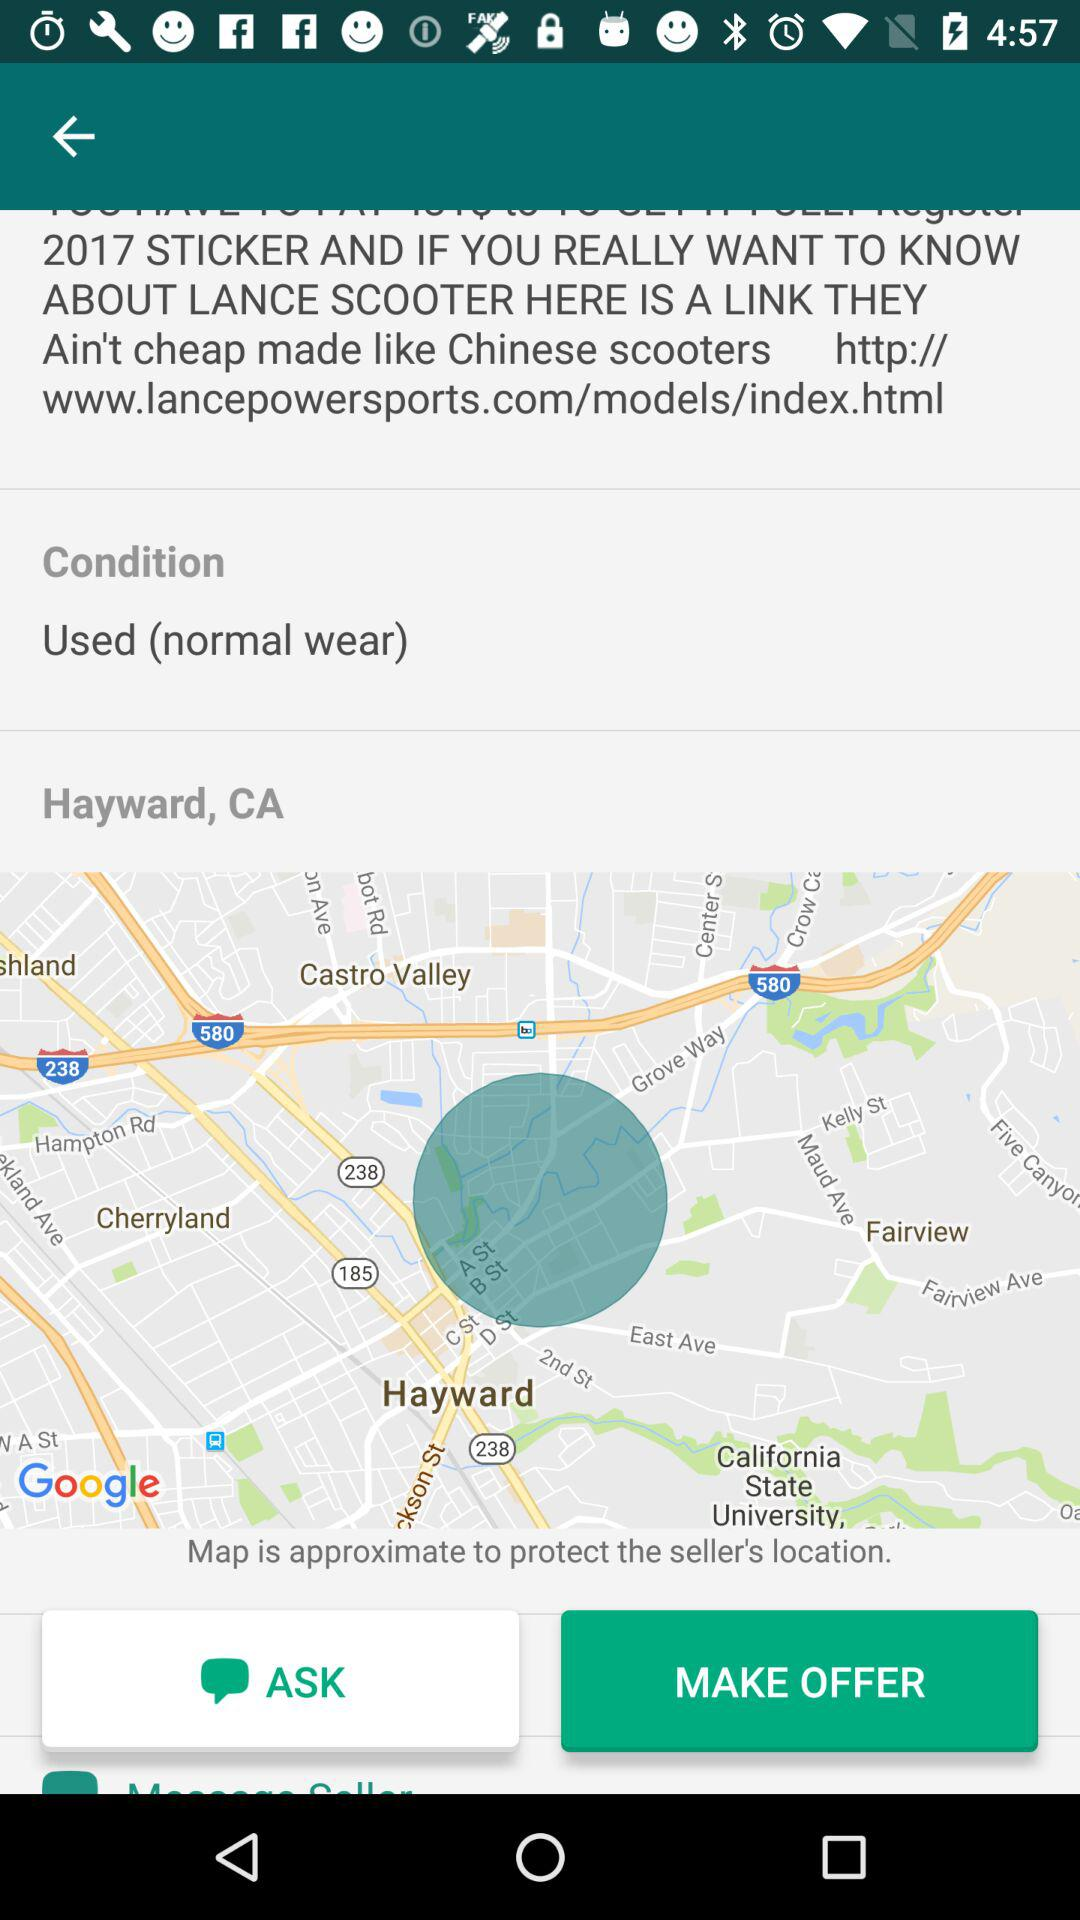What is the link address? The link address is http://www.lancepowersports.com/models/index.html. 